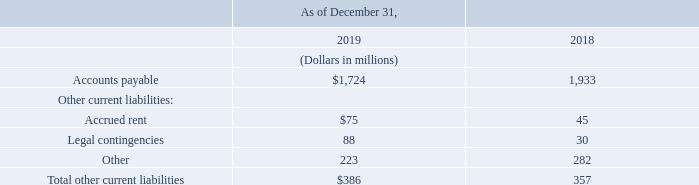Selected Current Liabilities
Current liabilities reflected in our consolidated balance sheets include accounts payable and other current liabilities as follows:
Included in accounts payable at December 31, 2019 and 2018, were (i) $106 million and $86 million, respectively, representing book overdrafts and (ii) $469 million and $434 million, respectively, associated with capital expenditures.
What do the current liabilities reflected in the consolidated balance sheets include? Accounts payable and other current liabilities. What are the items included in accounts payable? Book overdrafts, capital expenditures. What are the items included under Other current liabilities? Accrued rent, legal contingencies, other. Which year has a larger amount of accounts payable associated with capital expenditures? 469>434
Answer: 2019. What is the change in accrued rent in 2019?
Answer scale should be: million. 75-45
Answer: 30. What is the percentage change in legal contingencies in 2019?
Answer scale should be: percent. (88-30)/30
Answer: 193.33. 